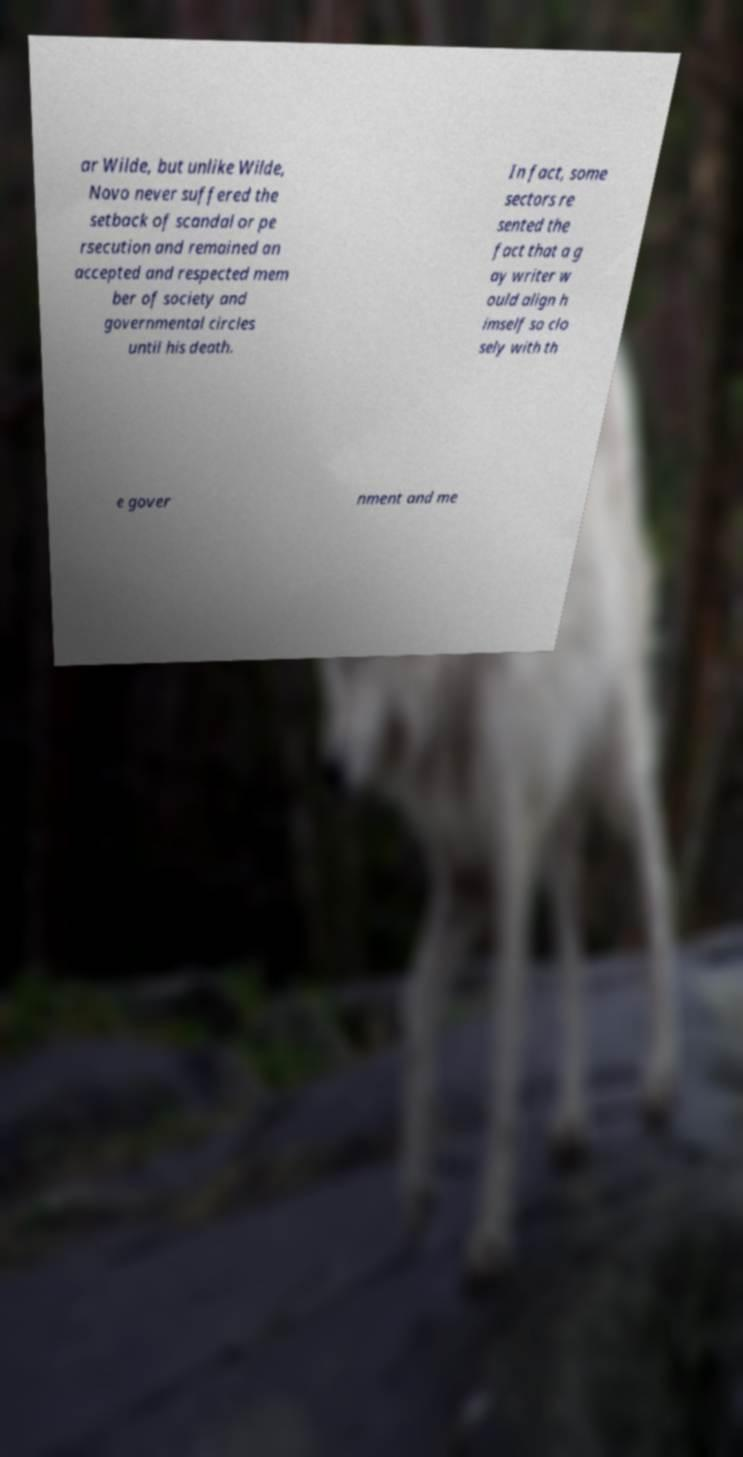Could you assist in decoding the text presented in this image and type it out clearly? ar Wilde, but unlike Wilde, Novo never suffered the setback of scandal or pe rsecution and remained an accepted and respected mem ber of society and governmental circles until his death. In fact, some sectors re sented the fact that a g ay writer w ould align h imself so clo sely with th e gover nment and me 